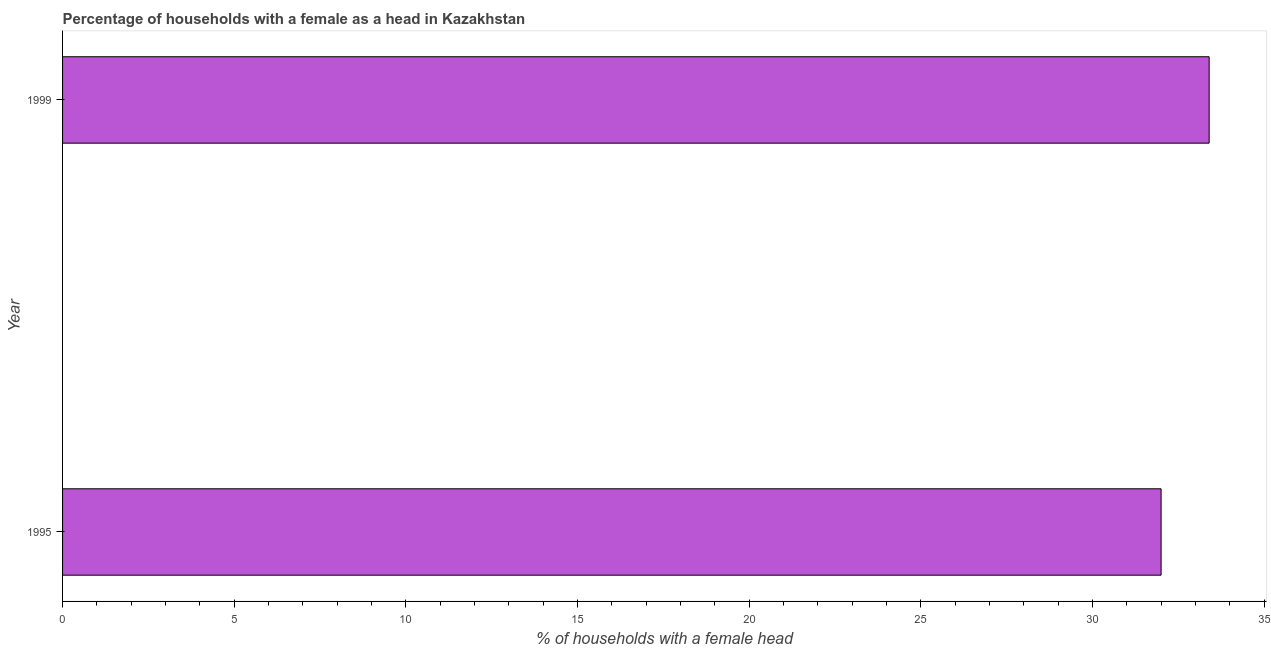Does the graph contain any zero values?
Your answer should be compact. No. Does the graph contain grids?
Make the answer very short. No. What is the title of the graph?
Offer a very short reply. Percentage of households with a female as a head in Kazakhstan. What is the label or title of the X-axis?
Provide a succinct answer. % of households with a female head. What is the label or title of the Y-axis?
Your answer should be compact. Year. What is the number of female supervised households in 1999?
Give a very brief answer. 33.4. Across all years, what is the maximum number of female supervised households?
Offer a terse response. 33.4. What is the sum of the number of female supervised households?
Provide a succinct answer. 65.4. What is the average number of female supervised households per year?
Your answer should be compact. 32.7. What is the median number of female supervised households?
Provide a short and direct response. 32.7. In how many years, is the number of female supervised households greater than 33 %?
Give a very brief answer. 1. Do a majority of the years between 1999 and 1995 (inclusive) have number of female supervised households greater than 10 %?
Your answer should be compact. No. What is the ratio of the number of female supervised households in 1995 to that in 1999?
Keep it short and to the point. 0.96. In how many years, is the number of female supervised households greater than the average number of female supervised households taken over all years?
Give a very brief answer. 1. How many bars are there?
Your response must be concise. 2. Are all the bars in the graph horizontal?
Offer a very short reply. Yes. How many years are there in the graph?
Provide a succinct answer. 2. Are the values on the major ticks of X-axis written in scientific E-notation?
Ensure brevity in your answer.  No. What is the % of households with a female head of 1999?
Give a very brief answer. 33.4. What is the ratio of the % of households with a female head in 1995 to that in 1999?
Offer a very short reply. 0.96. 